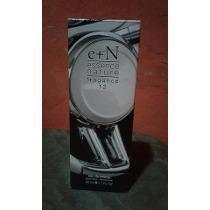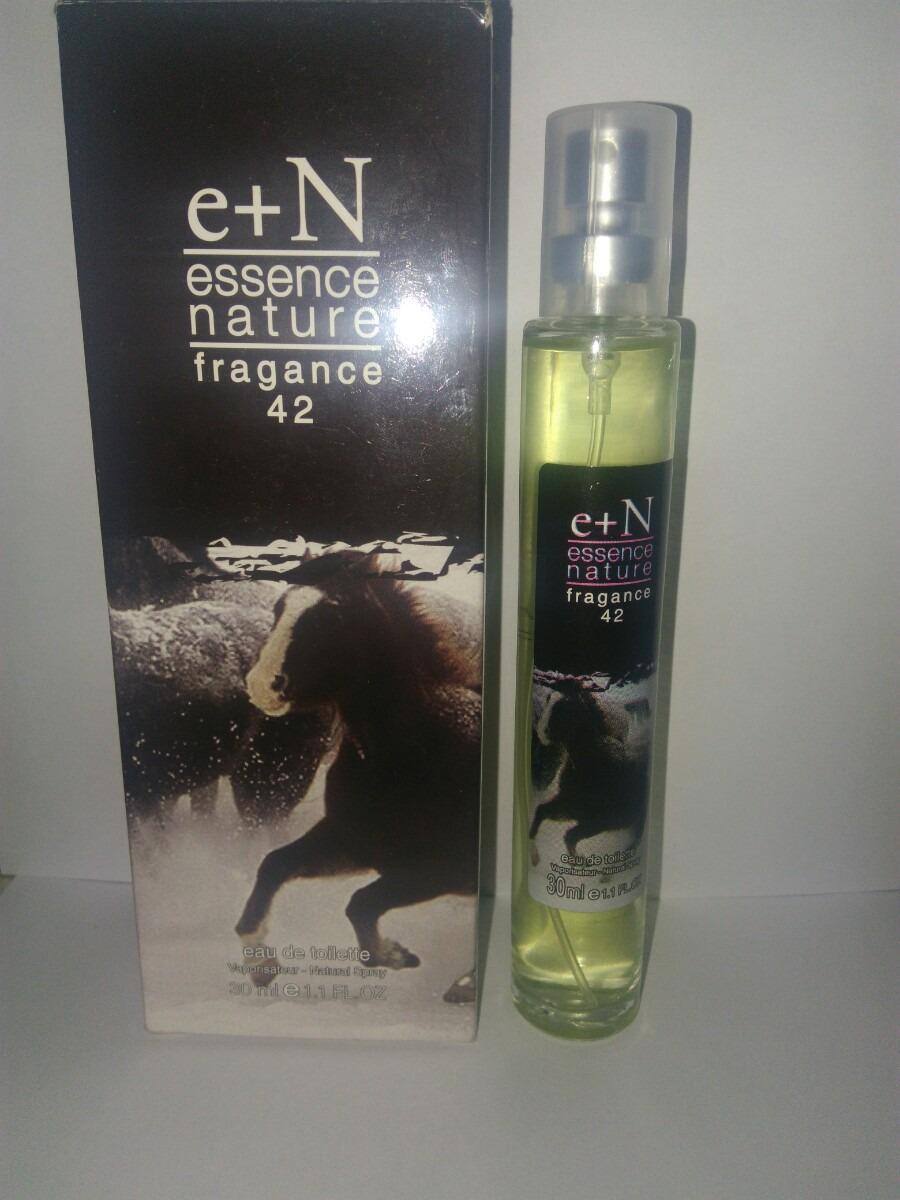The first image is the image on the left, the second image is the image on the right. For the images shown, is this caption "An image shows a product with a galloping horse on the front of the package." true? Answer yes or no. Yes. The first image is the image on the left, the second image is the image on the right. Evaluate the accuracy of this statement regarding the images: "A pink perfume bottle is next to its box in the left image.". Is it true? Answer yes or no. No. 